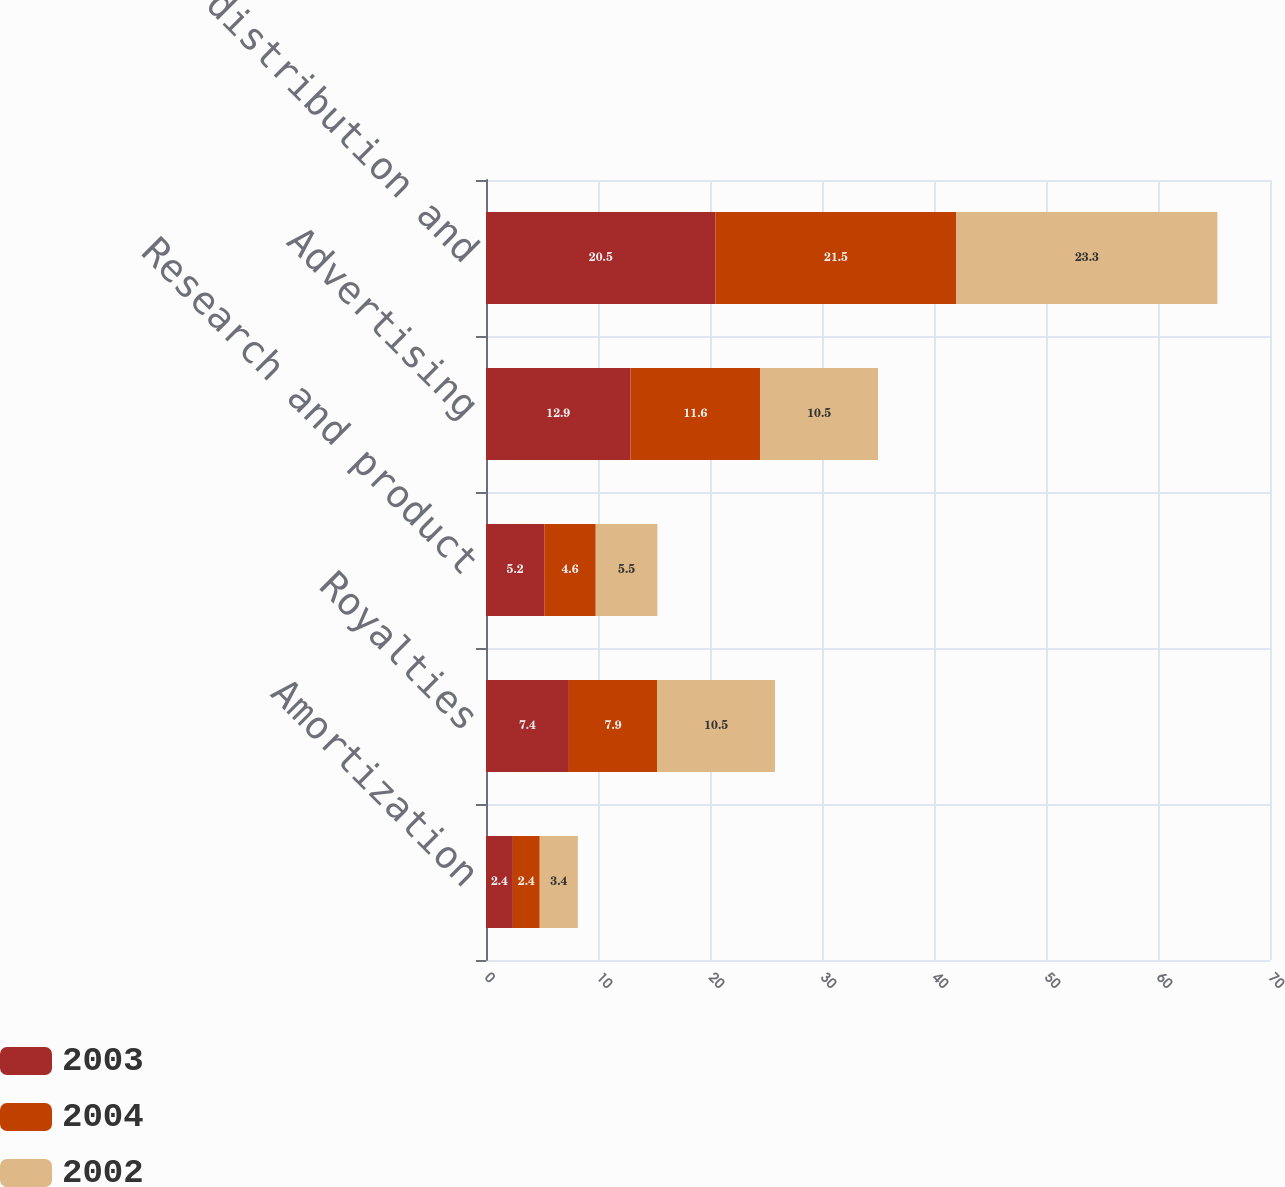Convert chart to OTSL. <chart><loc_0><loc_0><loc_500><loc_500><stacked_bar_chart><ecel><fcel>Amortization<fcel>Royalties<fcel>Research and product<fcel>Advertising<fcel>Selling distribution and<nl><fcel>2003<fcel>2.4<fcel>7.4<fcel>5.2<fcel>12.9<fcel>20.5<nl><fcel>2004<fcel>2.4<fcel>7.9<fcel>4.6<fcel>11.6<fcel>21.5<nl><fcel>2002<fcel>3.4<fcel>10.5<fcel>5.5<fcel>10.5<fcel>23.3<nl></chart> 